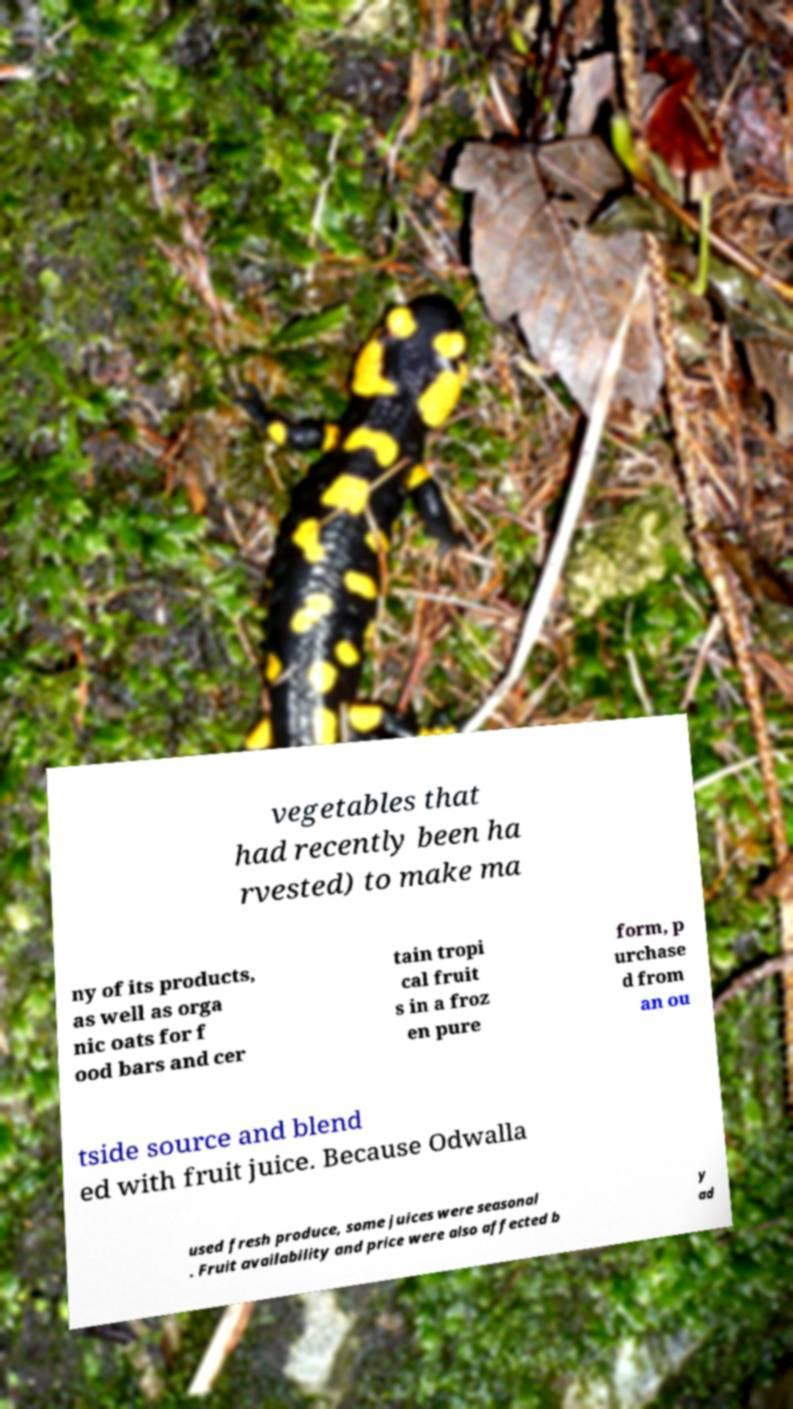Can you accurately transcribe the text from the provided image for me? vegetables that had recently been ha rvested) to make ma ny of its products, as well as orga nic oats for f ood bars and cer tain tropi cal fruit s in a froz en pure form, p urchase d from an ou tside source and blend ed with fruit juice. Because Odwalla used fresh produce, some juices were seasonal . Fruit availability and price were also affected b y ad 